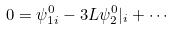Convert formula to latex. <formula><loc_0><loc_0><loc_500><loc_500>0 = \psi _ { 1 i } ^ { 0 } - 3 L \psi _ { 2 } ^ { 0 } | _ { i } + \cdots</formula> 